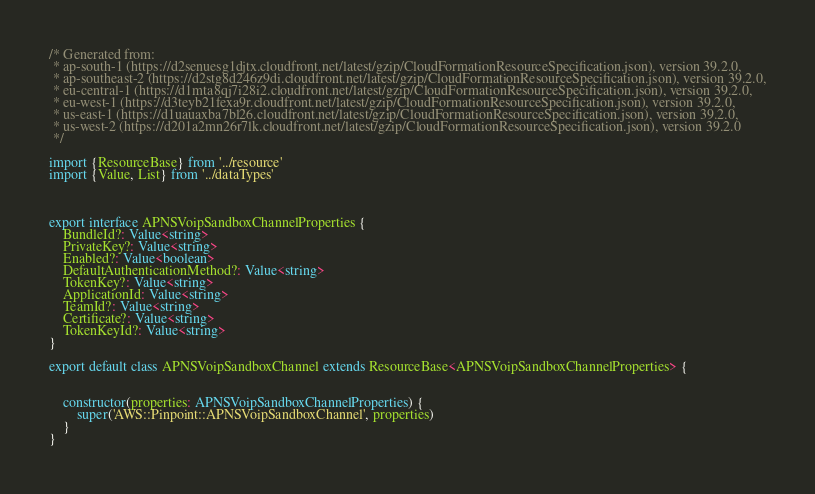Convert code to text. <code><loc_0><loc_0><loc_500><loc_500><_TypeScript_>/* Generated from: 
 * ap-south-1 (https://d2senuesg1djtx.cloudfront.net/latest/gzip/CloudFormationResourceSpecification.json), version 39.2.0,
 * ap-southeast-2 (https://d2stg8d246z9di.cloudfront.net/latest/gzip/CloudFormationResourceSpecification.json), version 39.2.0,
 * eu-central-1 (https://d1mta8qj7i28i2.cloudfront.net/latest/gzip/CloudFormationResourceSpecification.json), version 39.2.0,
 * eu-west-1 (https://d3teyb21fexa9r.cloudfront.net/latest/gzip/CloudFormationResourceSpecification.json), version 39.2.0,
 * us-east-1 (https://d1uauaxba7bl26.cloudfront.net/latest/gzip/CloudFormationResourceSpecification.json), version 39.2.0,
 * us-west-2 (https://d201a2mn26r7lk.cloudfront.net/latest/gzip/CloudFormationResourceSpecification.json), version 39.2.0
 */
   
import {ResourceBase} from '../resource'
import {Value, List} from '../dataTypes'



export interface APNSVoipSandboxChannelProperties {
    BundleId?: Value<string>
    PrivateKey?: Value<string>
    Enabled?: Value<boolean>
    DefaultAuthenticationMethod?: Value<string>
    TokenKey?: Value<string>
    ApplicationId: Value<string>
    TeamId?: Value<string>
    Certificate?: Value<string>
    TokenKeyId?: Value<string>
}

export default class APNSVoipSandboxChannel extends ResourceBase<APNSVoipSandboxChannelProperties> {


    constructor(properties: APNSVoipSandboxChannelProperties) {
        super('AWS::Pinpoint::APNSVoipSandboxChannel', properties)
    }
}
</code> 